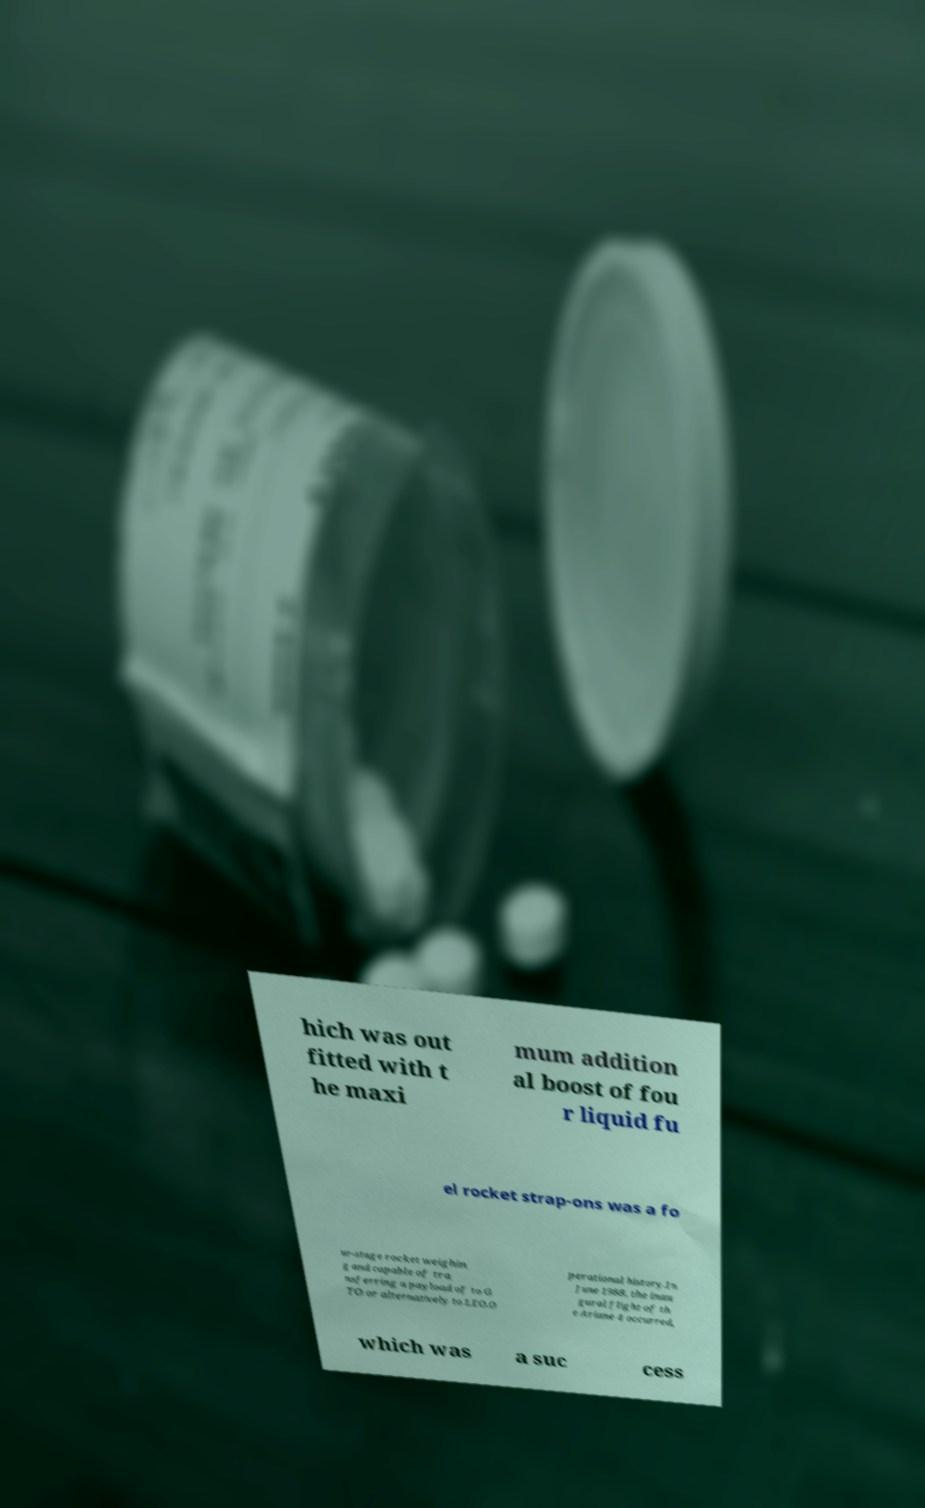Can you read and provide the text displayed in the image?This photo seems to have some interesting text. Can you extract and type it out for me? hich was out fitted with t he maxi mum addition al boost of fou r liquid fu el rocket strap-ons was a fo ur-stage rocket weighin g and capable of tra nsferring a payload of to G TO or alternatively to LEO.O perational history.In June 1988, the inau gural flight of th e Ariane 4 occurred, which was a suc cess 